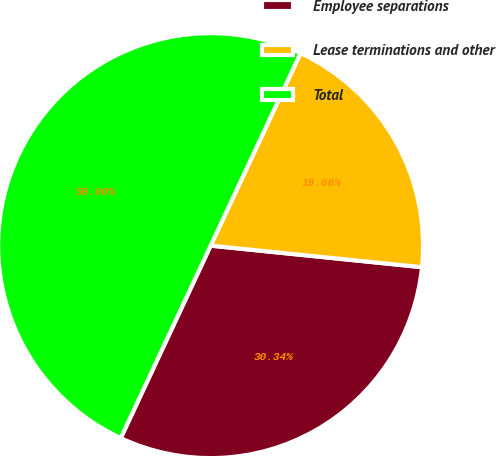Convert chart. <chart><loc_0><loc_0><loc_500><loc_500><pie_chart><fcel>Employee separations<fcel>Lease terminations and other<fcel>Total<nl><fcel>30.34%<fcel>19.66%<fcel>50.0%<nl></chart> 